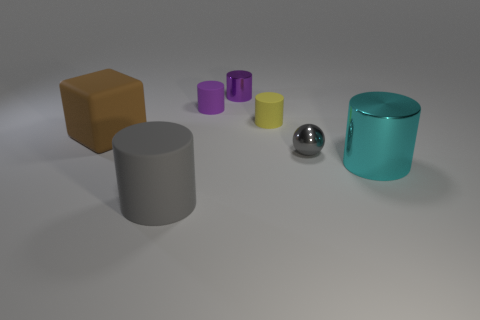Subtract all cubes. How many objects are left? 6 Subtract 1 balls. How many balls are left? 0 Subtract all green cubes. Subtract all brown spheres. How many cubes are left? 1 Subtract all brown balls. How many yellow cylinders are left? 1 Subtract all tiny purple metallic cylinders. Subtract all big shiny cubes. How many objects are left? 6 Add 6 rubber objects. How many rubber objects are left? 10 Add 5 large brown metallic cylinders. How many large brown metallic cylinders exist? 5 Add 2 brown rubber objects. How many objects exist? 9 Subtract all yellow cylinders. How many cylinders are left? 4 Subtract all metallic cylinders. How many cylinders are left? 3 